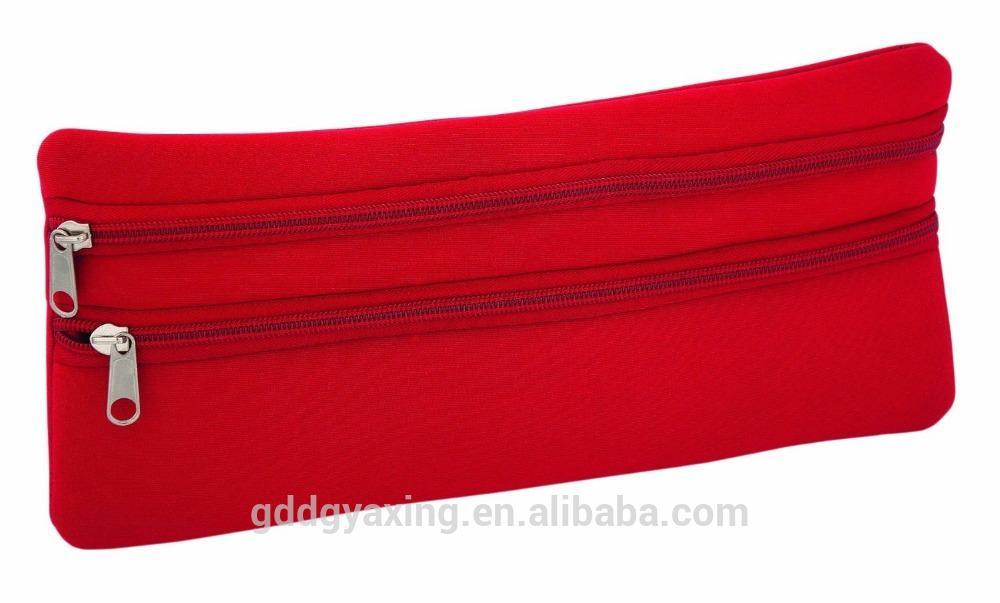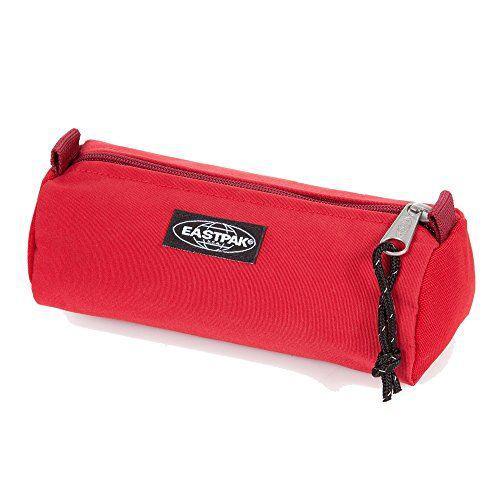The first image is the image on the left, the second image is the image on the right. For the images shown, is this caption "There is one brand label showing on the pencil pouch on the right." true? Answer yes or no. Yes. The first image is the image on the left, the second image is the image on the right. Examine the images to the left and right. Is the description "The pencil case on the left is not flat; it's shaped more like a rectangular box." accurate? Answer yes or no. No. 